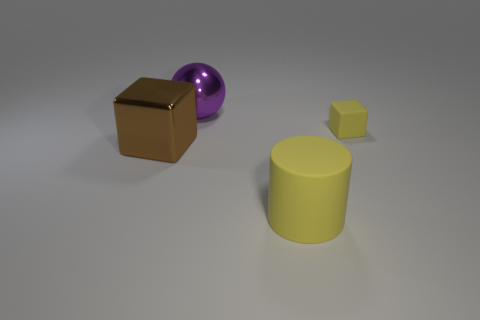What is the color of the big rubber cylinder to the right of the large metallic object that is in front of the tiny yellow cube?
Your response must be concise. Yellow. Is there a purple metal ball that is behind the purple ball to the left of the yellow thing to the left of the tiny object?
Provide a succinct answer. No. There is a ball that is made of the same material as the big brown cube; what color is it?
Provide a succinct answer. Purple. What number of yellow cylinders have the same material as the small yellow object?
Offer a very short reply. 1. Is the material of the tiny block the same as the block that is left of the big matte cylinder?
Offer a terse response. No. What number of objects are either yellow objects on the right side of the big yellow cylinder or tiny rubber spheres?
Give a very brief answer. 1. There is a yellow rubber object to the left of the yellow matte object to the right of the object in front of the big brown object; what size is it?
Your answer should be very brief. Large. What is the material of the thing that is the same color as the matte block?
Offer a very short reply. Rubber. Is there any other thing that has the same shape as the big yellow rubber object?
Ensure brevity in your answer.  No. What size is the cube on the left side of the yellow matte thing that is behind the brown shiny block?
Your answer should be compact. Large. 